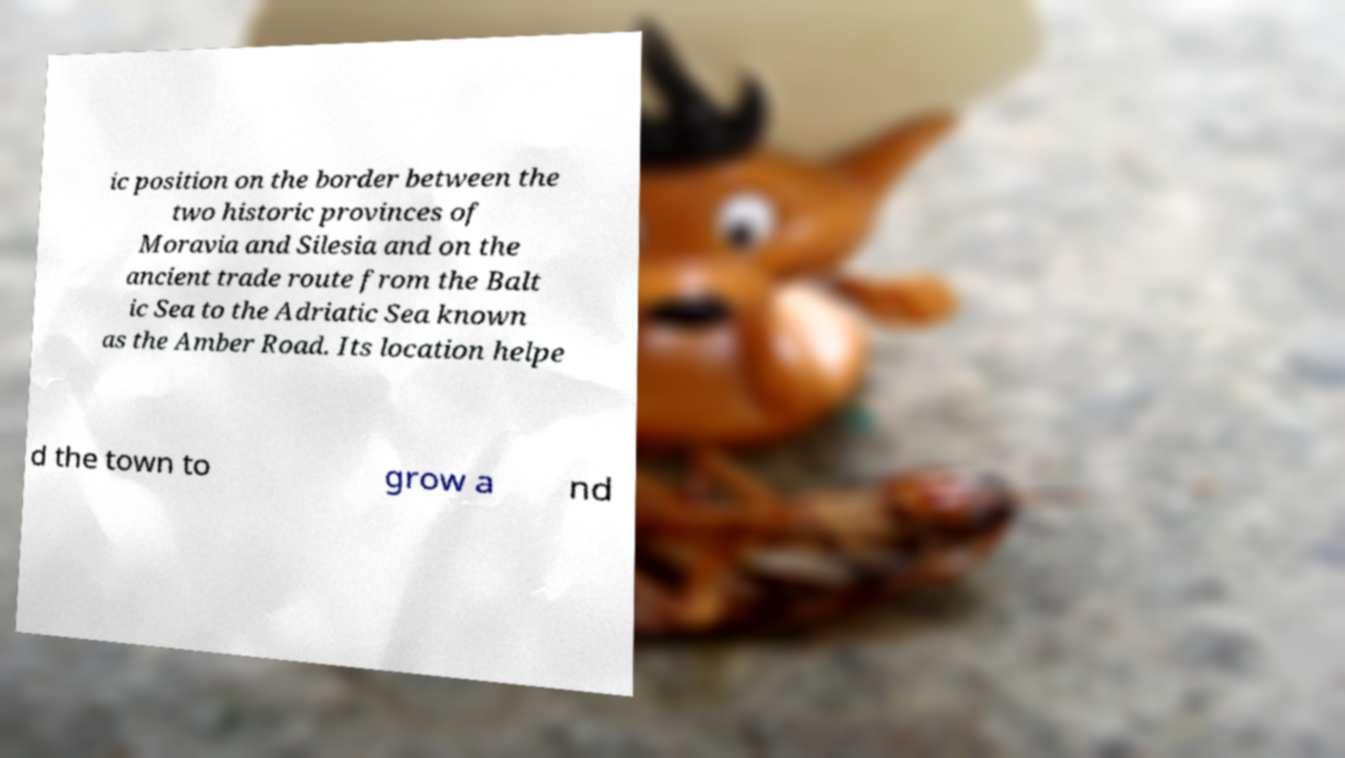Could you extract and type out the text from this image? ic position on the border between the two historic provinces of Moravia and Silesia and on the ancient trade route from the Balt ic Sea to the Adriatic Sea known as the Amber Road. Its location helpe d the town to grow a nd 